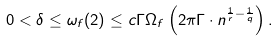<formula> <loc_0><loc_0><loc_500><loc_500>0 < \delta \leq \omega _ { f } ( 2 ) \leq c \Gamma \Omega _ { f } \left ( 2 \pi \Gamma \cdot n ^ { \frac { 1 } { r } - \frac { 1 } { q } } \right ) .</formula> 